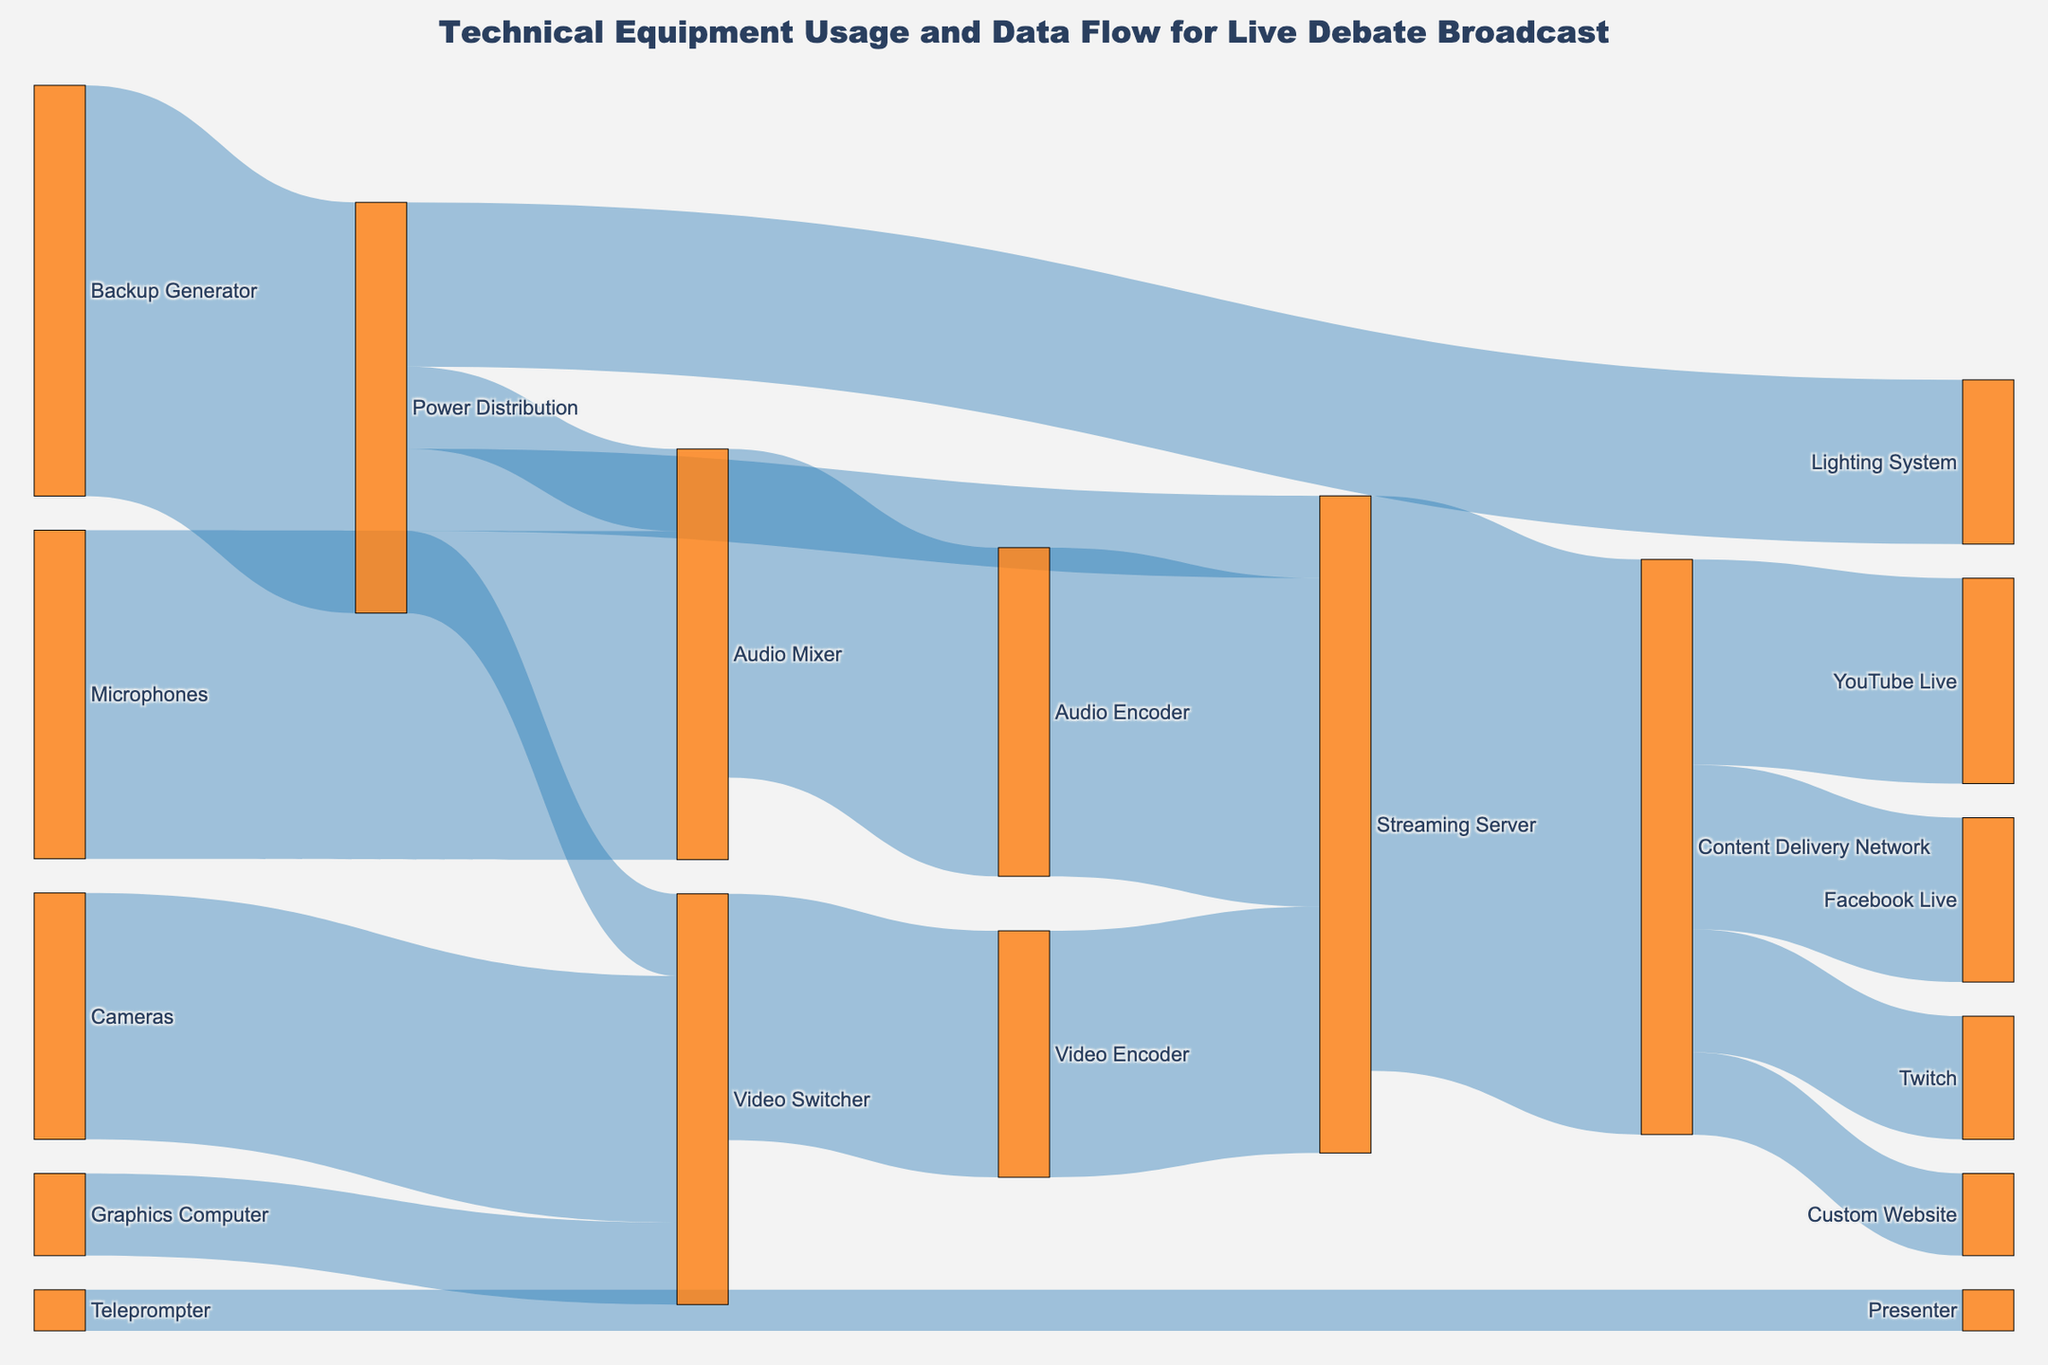How many data flows into the Streaming Server? To determine how many data points are flowing into the Streaming Server, observe the connections leading directly to it from other nodes. The Audio Encoder and Video Encoder each have flows going into the Streaming Server, with values of 8 and 6, respectively.
Answer: 2 What is the total value of the data going through the Content Delivery Network? Sum all values corresponding to the connections into and out of the Content Delivery Network. The incoming value from the Streaming Server is 14. The outgoing values are to YouTube Live (5), Facebook Live (4), Twitch (3), and Custom Website (2).
Answer: 28 Which device receives the highest number of input data flows? To find the device receiving the highest number of input data flows, count the incoming connections for each node. The Content Delivery Network receives inputs from the Streaming Server with a total of 14, which is the highest among all nodes.
Answer: Content Delivery Network How many data flows directly involve the Audio Mixer? Identify the connections in which the Audio Mixer appears either as a source or target. The Audio Mixer is involved in flows with the Microphones (8), Audio Encoder (8), and Power Distribution (2).
Answer: 3 Compare the total data value moving through the Video Switcher and Audio Encoder. Which one processes more data? Sum the values of connections involving each node. The Video Switcher has incoming data from Cameras (6) and Graphics Computer (2), totaling 8. The Audio Encoder only receives data from the Audio Mixer (8). Both process the same total amount of data.
Answer: Equal What is the combined value of audio-related data flows? Sum the values of all connections involving audio equipment, including Microphones to Audio Mixer (8), Audio Mixer to Audio Encoder (8), Audio Encoder to Streaming Server (8), and Power Distribution to Audio Mixer (2).
Answer: 26 From where does the Power Distribution distribute its data? Note the target nodes receiving data from the Power Distribution: Audio Mixer (2), Video Switcher (2), Streaming Server (2), and Lighting System (4).
Answer: Audio Mixer, Video Switcher, Streaming Server, Lighting System How many output destinations does the Video Encoder have, and what are they? Identify the connections where the Video Encoder is the source. The Video Encoder sends data to the Streaming Server, with a value of 6.
Answer: 1, Streaming Server Which device ensures a backup power supply to other devices, and how many devices does it support? The Backup Generator distributes its power through the Power Distribution, which then supports Audio Mixer (2), Video Switcher (2), Streaming Server (2), and Lighting System (4).
Answer: Power Distribution, 4 